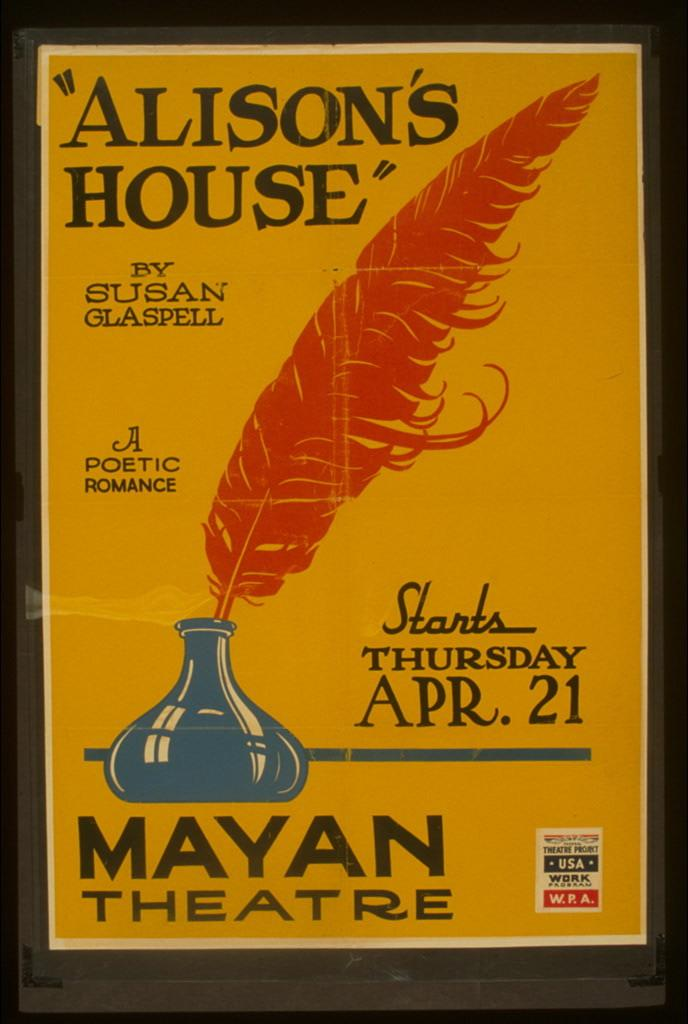<image>
Relay a brief, clear account of the picture shown. An advertisement for Allison's House by Susan Glaspell which also shows it starting Thursday Apr. 21. at the Mayan Theatre. 